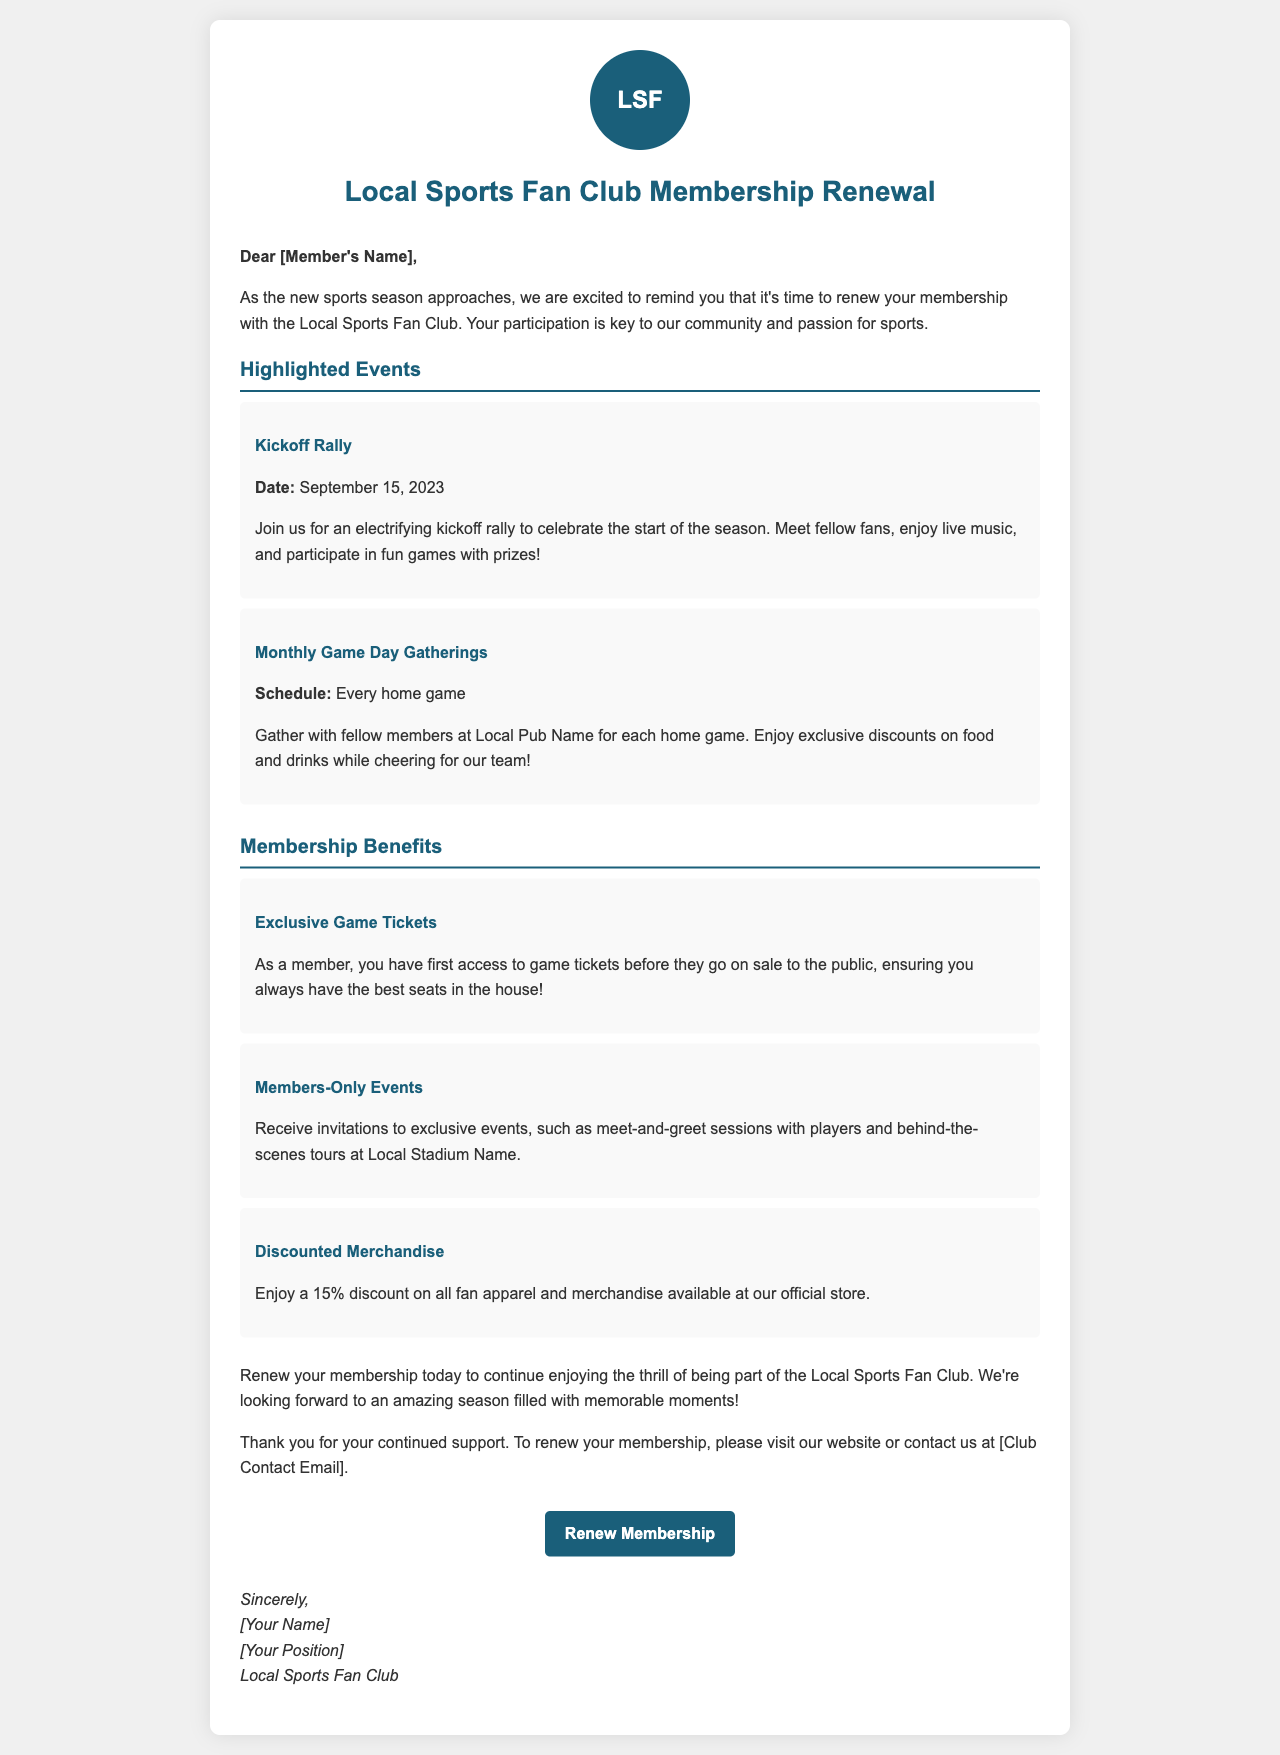What is the date of the Kickoff Rally? The Kickoff Rally is scheduled for September 15, 2023.
Answer: September 15, 2023 What is one benefit of being a member? Members enjoy exclusive game tickets before the general public.
Answer: Exclusive Game Tickets How often are the Monthly Game Day Gatherings held? These gatherings occur every home game during the season.
Answer: Every home game What discount do members receive on merchandise? Members receive a 15% discount on all fan apparel and merchandise.
Answer: 15% What type of events will members be invited to? Members will receive invitations to exclusive events like meet-and-greet sessions with players.
Answer: Members-Only Events When should members renew their membership? Members should renew their membership before the start of the new sports season.
Answer: Before the new sports season What is the main purpose of this letter? The purpose of the letter is to remind members to renew their membership.
Answer: Membership renewal reminder Who is the message signed by? The signature includes [Your Name] and [Your Position] from the Local Sports Fan Club.
Answer: [Your Name] and [Your Position] 